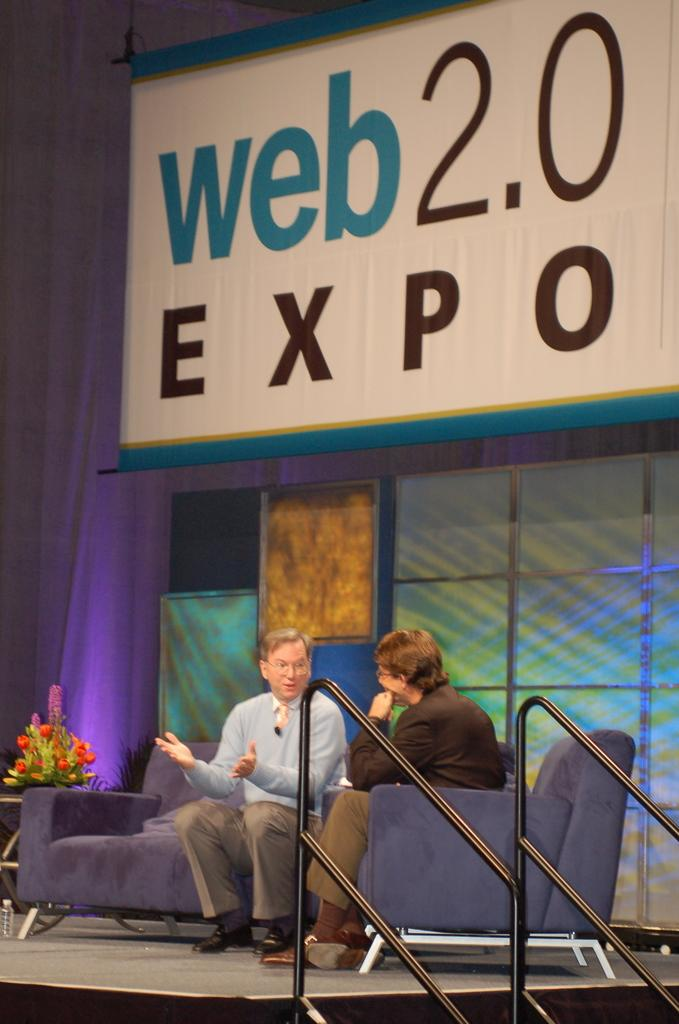What are the persons in the image doing? The persons in the image are sitting on the couches. What can be seen on the side table? A flower vase is placed on the side table. What is located in the background of the image? There is a name board and curtains visible in the background. What type of structure is visible in the background? Walls are visible in the background. What type of songs can be heard in the background of the image? There is no audio component in the image, so it is not possible to determine what songs might be heard. 